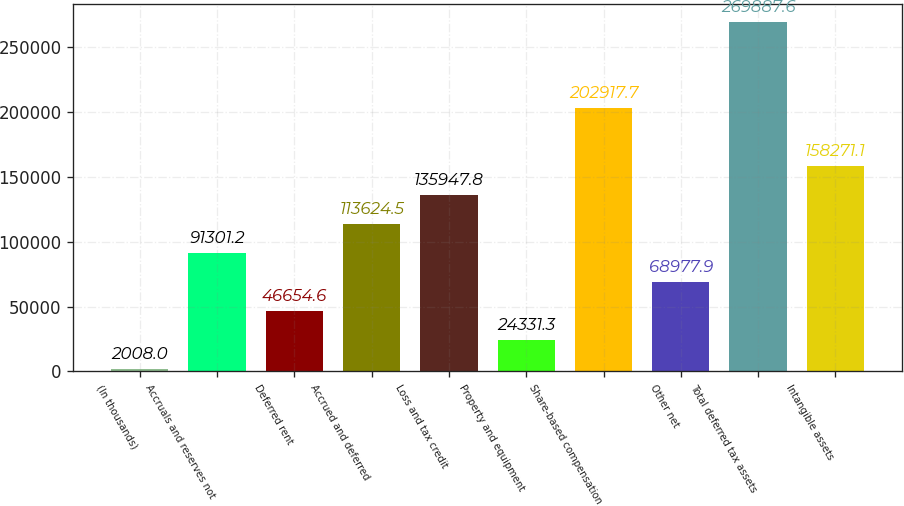Convert chart to OTSL. <chart><loc_0><loc_0><loc_500><loc_500><bar_chart><fcel>(In thousands)<fcel>Accruals and reserves not<fcel>Deferred rent<fcel>Accrued and deferred<fcel>Loss and tax credit<fcel>Property and equipment<fcel>Share-based compensation<fcel>Other net<fcel>Total deferred tax assets<fcel>Intangible assets<nl><fcel>2008<fcel>91301.2<fcel>46654.6<fcel>113624<fcel>135948<fcel>24331.3<fcel>202918<fcel>68977.9<fcel>269888<fcel>158271<nl></chart> 